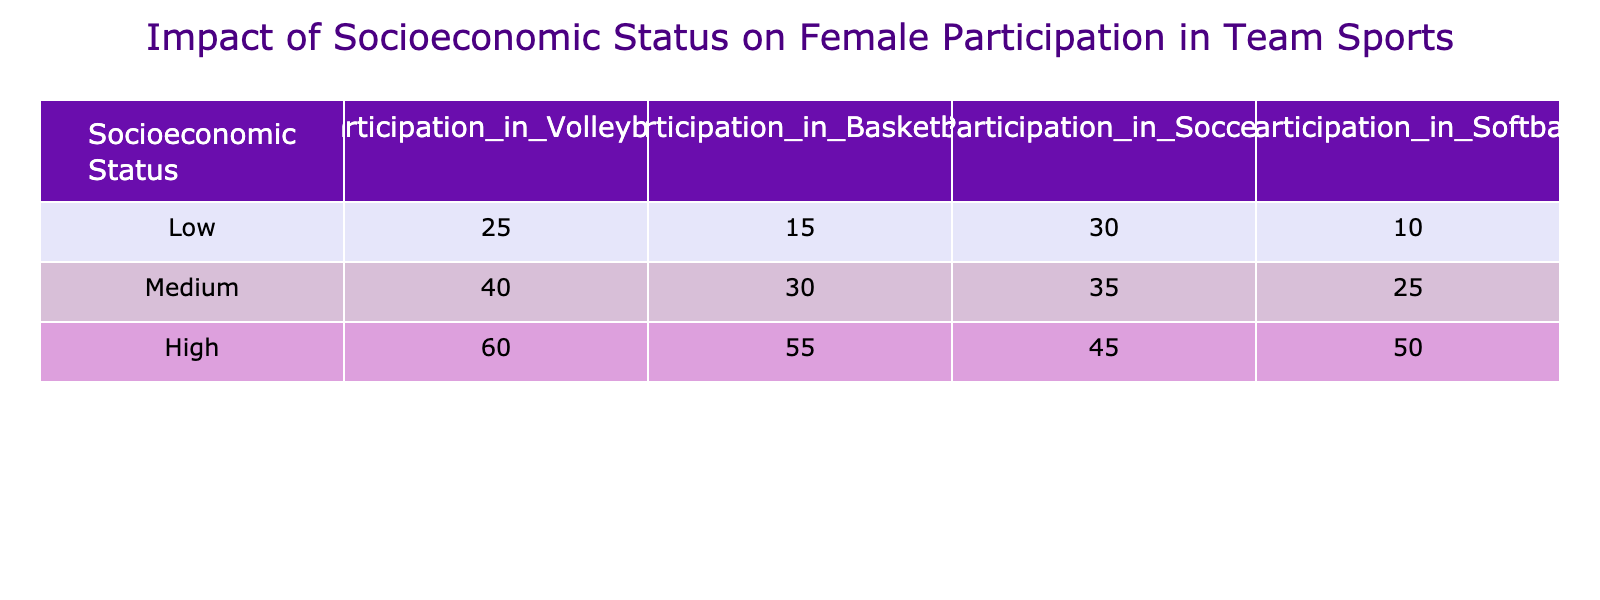What is the participation rate of females from low socioeconomic status in soccer? The table shows the participation in soccer under the "Low" row. According to the data, the value for low socioeconomic status in soccer is 30.
Answer: 30 What sport has the highest participation among females from medium socioeconomic status? Looking at the medium socioeconomic status row, the participation rates for volleyball, basketball, soccer, and softball are 40, 30, 35, and 25, respectively. The highest value is 40, which corresponds to volleyball.
Answer: Volleyball Is the participation rate of females from high socioeconomic status in softball greater than in volleyball? From the high row in the table, volleyball participation is 60, and softball participation is 50. Since 50 is less than 60, the statement is false.
Answer: No What is the total participation of females from low socioeconomic status across all sports? The total participation for low socioeconomic status is calculated by adding the values: 25 (volleyball) + 15 (basketball) + 30 (soccer) + 10 (softball) = 80.
Answer: 80 Are more females from medium socioeconomic status participating in basketball or soccer? The participation rates for basketball and soccer under the medium socioeconomic status are 30 and 35, respectively. 35 (soccer) is greater than 30 (basketball), so more females participate in soccer.
Answer: Yes What is the average participation rate of females in volleyball across all socioeconomic statuses? To find the average, we sum the participation rates in volleyball (25 + 40 + 60) and divide by the number of groups (3). This gives us (125/3) = approximately 41.67.
Answer: 41.67 Which socioeconomic status has the lowest total participation across all sports? We need to calculate the total participation for each socioeconomic status: Low (80), Medium (130), and High (210). The lowest total is for low socioeconomic status with 80.
Answer: Low What is the difference in participation rates between soccer and basketball for high socioeconomic status? Looking at the participation rates for high socioeconomic status, soccer has 45 and basketball has 55. The difference is calculated by subtracting these values: 55 - 45 = 10.
Answer: 10 